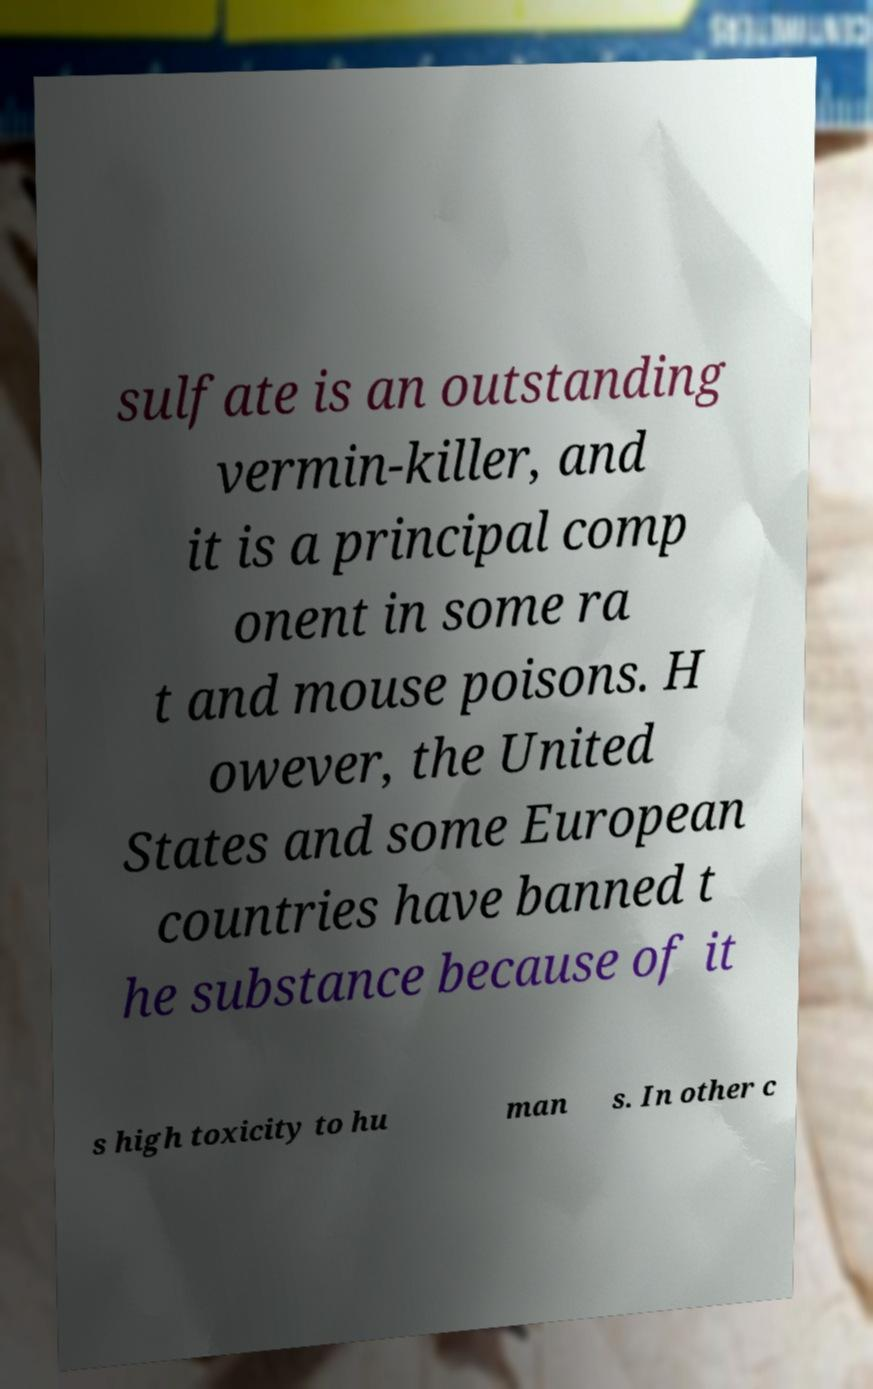Can you accurately transcribe the text from the provided image for me? sulfate is an outstanding vermin-killer, and it is a principal comp onent in some ra t and mouse poisons. H owever, the United States and some European countries have banned t he substance because of it s high toxicity to hu man s. In other c 